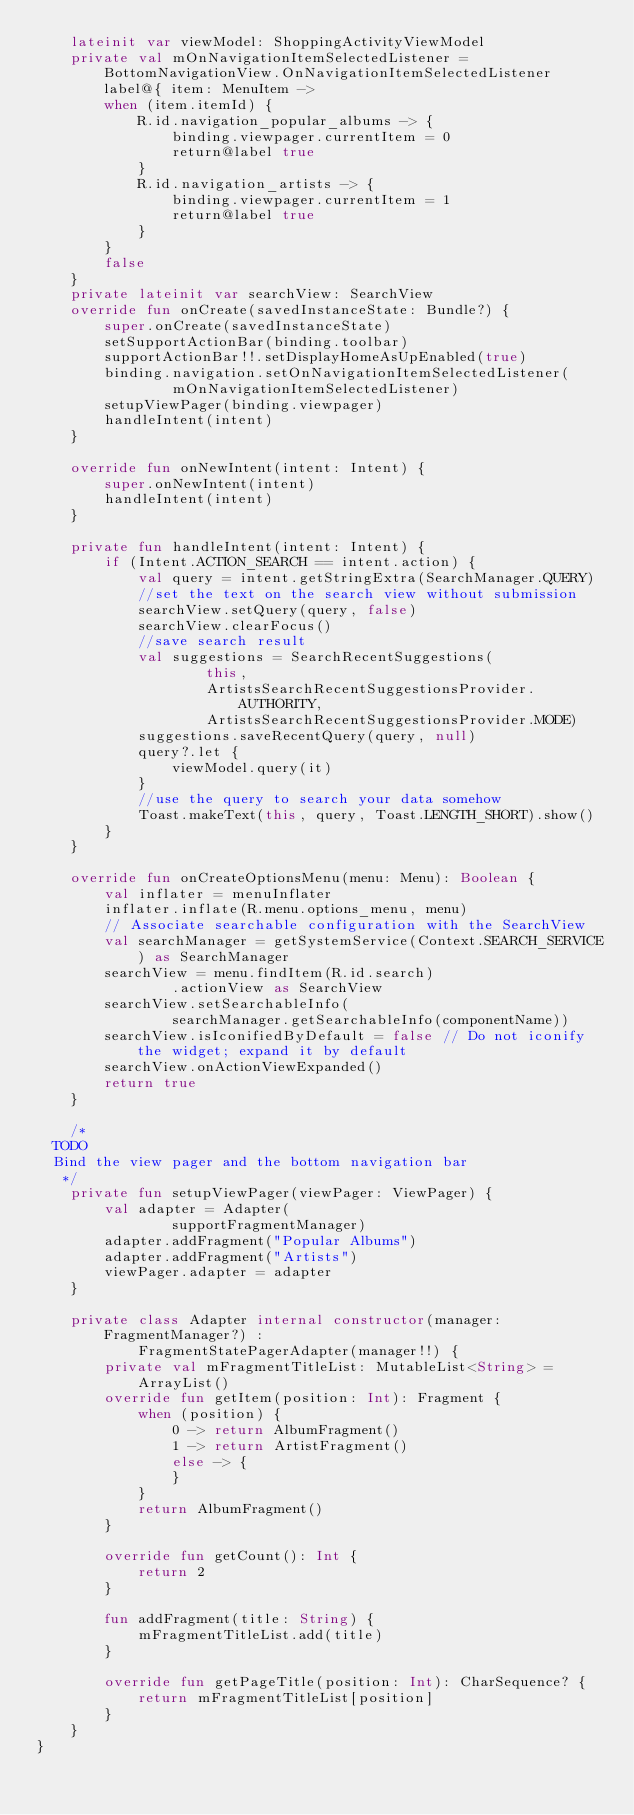Convert code to text. <code><loc_0><loc_0><loc_500><loc_500><_Kotlin_>    lateinit var viewModel: ShoppingActivityViewModel
    private val mOnNavigationItemSelectedListener = BottomNavigationView.OnNavigationItemSelectedListener label@{ item: MenuItem ->
        when (item.itemId) {
            R.id.navigation_popular_albums -> {
                binding.viewpager.currentItem = 0
                return@label true
            }
            R.id.navigation_artists -> {
                binding.viewpager.currentItem = 1
                return@label true
            }
        }
        false
    }
    private lateinit var searchView: SearchView
    override fun onCreate(savedInstanceState: Bundle?) {
        super.onCreate(savedInstanceState)
        setSupportActionBar(binding.toolbar)
        supportActionBar!!.setDisplayHomeAsUpEnabled(true)
        binding.navigation.setOnNavigationItemSelectedListener(
                mOnNavigationItemSelectedListener)
        setupViewPager(binding.viewpager)
        handleIntent(intent)
    }

    override fun onNewIntent(intent: Intent) {
        super.onNewIntent(intent)
        handleIntent(intent)
    }

    private fun handleIntent(intent: Intent) {
        if (Intent.ACTION_SEARCH == intent.action) {
            val query = intent.getStringExtra(SearchManager.QUERY)
            //set the text on the search view without submission
            searchView.setQuery(query, false)
            searchView.clearFocus()
            //save search result
            val suggestions = SearchRecentSuggestions(
                    this,
                    ArtistsSearchRecentSuggestionsProvider.AUTHORITY,
                    ArtistsSearchRecentSuggestionsProvider.MODE)
            suggestions.saveRecentQuery(query, null)
            query?.let {
                viewModel.query(it)
            }
            //use the query to search your data somehow
            Toast.makeText(this, query, Toast.LENGTH_SHORT).show()
        }
    }

    override fun onCreateOptionsMenu(menu: Menu): Boolean {
        val inflater = menuInflater
        inflater.inflate(R.menu.options_menu, menu)
        // Associate searchable configuration with the SearchView
        val searchManager = getSystemService(Context.SEARCH_SERVICE) as SearchManager
        searchView = menu.findItem(R.id.search)
                .actionView as SearchView
        searchView.setSearchableInfo(
                searchManager.getSearchableInfo(componentName))
        searchView.isIconifiedByDefault = false // Do not iconify the widget; expand it by default
        searchView.onActionViewExpanded()
        return true
    }

    /*
  TODO
  Bind the view pager and the bottom navigation bar
   */
    private fun setupViewPager(viewPager: ViewPager) {
        val adapter = Adapter(
                supportFragmentManager)
        adapter.addFragment("Popular Albums")
        adapter.addFragment("Artists")
        viewPager.adapter = adapter
    }

    private class Adapter internal constructor(manager: FragmentManager?) :
            FragmentStatePagerAdapter(manager!!) {
        private val mFragmentTitleList: MutableList<String> = ArrayList()
        override fun getItem(position: Int): Fragment {
            when (position) {
                0 -> return AlbumFragment()
                1 -> return ArtistFragment()
                else -> {
                }
            }
            return AlbumFragment()
        }

        override fun getCount(): Int {
            return 2
        }

        fun addFragment(title: String) {
            mFragmentTitleList.add(title)
        }

        override fun getPageTitle(position: Int): CharSequence? {
            return mFragmentTitleList[position]
        }
    }
}</code> 